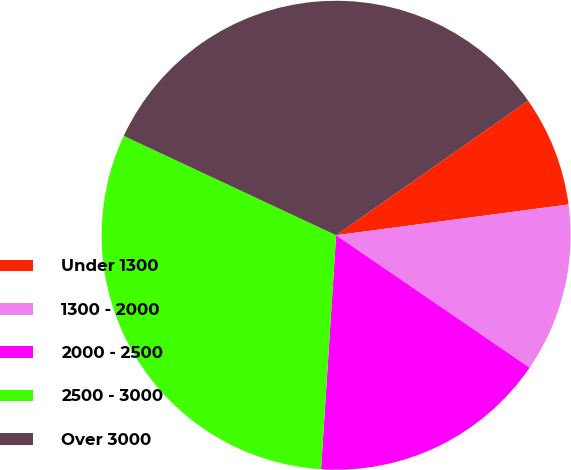Convert chart. <chart><loc_0><loc_0><loc_500><loc_500><pie_chart><fcel>Under 1300<fcel>1300 - 2000<fcel>2000 - 2500<fcel>2500 - 3000<fcel>Over 3000<nl><fcel>7.63%<fcel>11.65%<fcel>16.47%<fcel>30.94%<fcel>33.31%<nl></chart> 